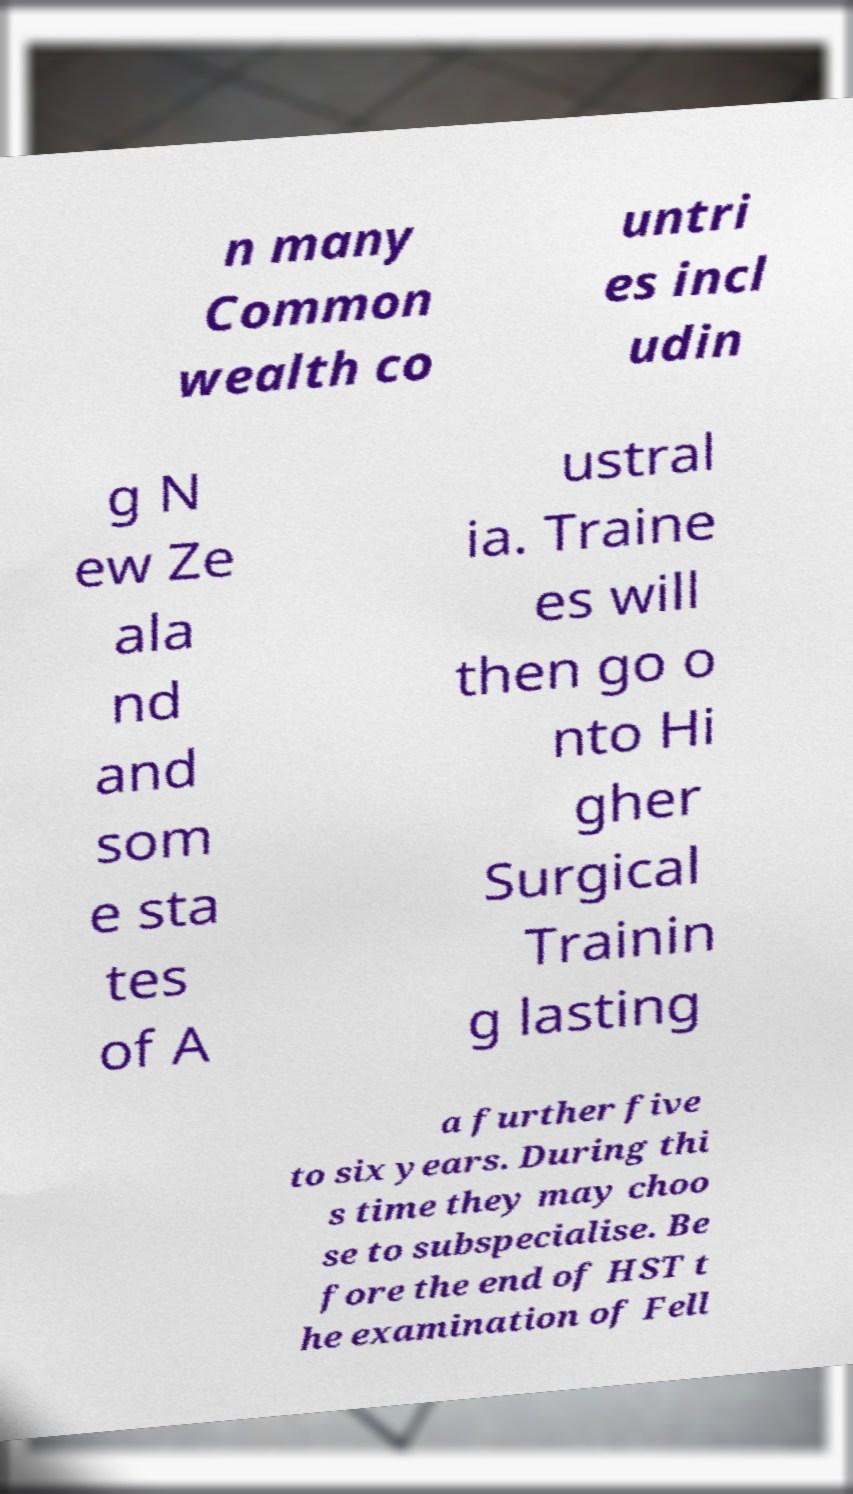I need the written content from this picture converted into text. Can you do that? n many Common wealth co untri es incl udin g N ew Ze ala nd and som e sta tes of A ustral ia. Traine es will then go o nto Hi gher Surgical Trainin g lasting a further five to six years. During thi s time they may choo se to subspecialise. Be fore the end of HST t he examination of Fell 